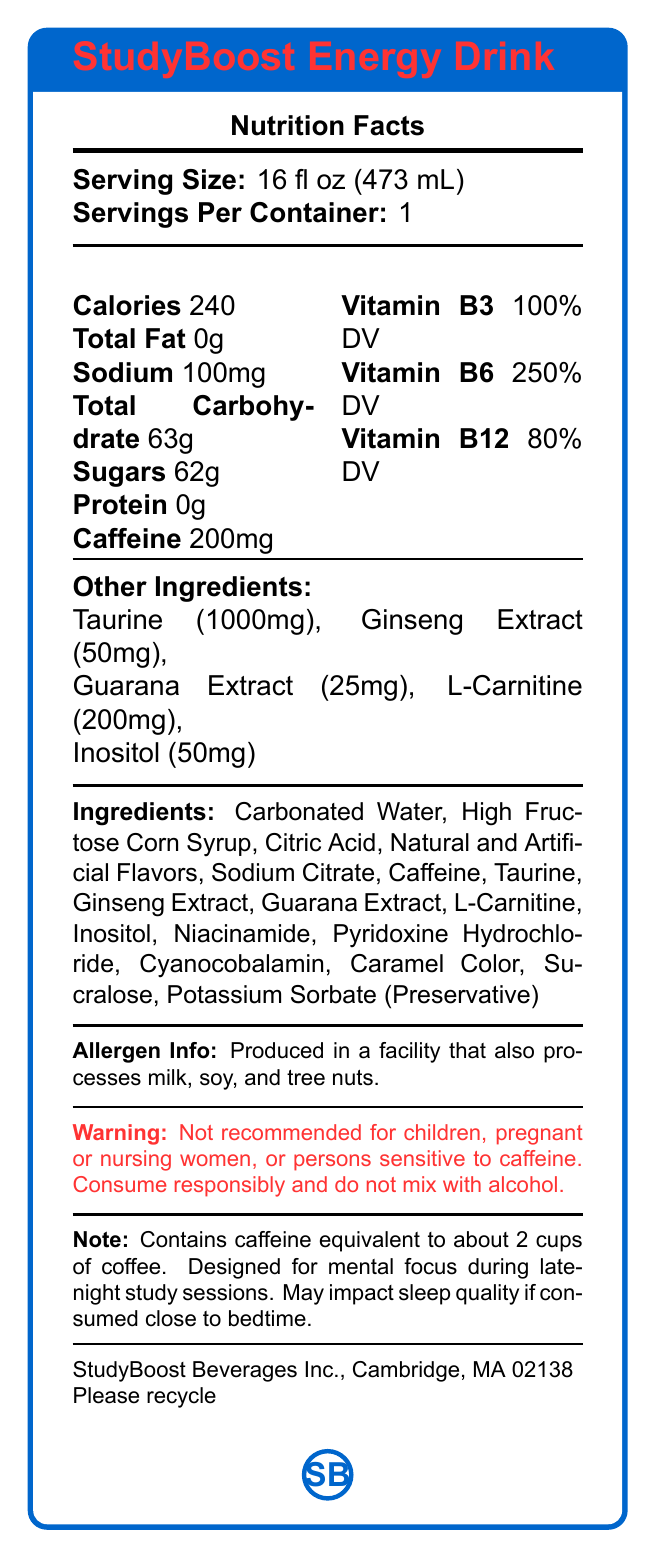what is the serving size? The serving size is explicitly mentioned at the top of the Nutrition Facts section.
Answer: 16 fl oz (473 mL) how many calories are in one serving? The calorie count is listed directly under "Calories" in the Nutrition Facts.
Answer: 240 what is the amount of caffeine in the drink? The caffeine content is listed along with other nutritional information.
Answer: 200mg how much sugar is in one serving of the energy drink? The sugar content is listed under "Sugars" in the Nutrition Facts section.
Answer: 62g which vitamins are included in this drink, and what are their daily values? The vitamins and their daily values are listed in the Nutrition Facts section.
Answer: Vitamin B3 (100% DV), Vitamin B6 (250% DV), Vitamin B12 (80% DV) how much sodium does this energy drink contain? Sodium content can be found in the standard nutritional listing in the Nutrition Facts section.
Answer: 100mg which of the following is not an ingredient in StudyBoost Energy Drink? A. Ginseng Extract B. L-Carnitine C. Vitamin D D. Citric Acid Vitamin D is not listed in the ingredients section.
Answer: C what is the purpose of this energy drink as mentioned in the document? A. Weight loss B. Mental focus and energy C. Muscle building D. Hydration The note at the bottom of the document states that the drink is designed for mental focus and energy for late-night study sessions.
Answer: B is the StudyBoost Energy Drink recommended for children or pregnant women? The consumer warning explicitly states that it is not recommended for children or pregnant or nursing women.
Answer: No summarize the main idea of this Nutrition Facts Label. The document provides detailed nutritional information, ingredient listing, and consumer warnings for the StudyBoost Energy Drink, emphasizing its components, servings, and usage warnings.
Answer: The StudyBoost Energy Drink provides information on its nutritional content, ingredients, and warnings. Each 16 fl oz serving contains 240 calories, 200mg of caffeine, high amounts of vitamins B3, B6, and B12, and significant sugars. The drink contains additional ingredients such as taurine, ginseng extract, and guarana extract and should be consumed responsibly, particularly due to its high caffeine content. how much taurine is present in the drink? The content of taurine is listed under "Other Ingredients".
Answer: 1000mg what are the possible allergens in this drink? The allergen information states that the product is produced in a facility that processes milk, soy, and tree nuts.
Answer: Milk, soy, and tree nuts is the energy drink suitable for mixing with alcohol? The consumer warning advises not to mix the energy drink with alcohol.
Answer: No what is the percentage Daily Value (% DV) of Vitamin B6 in this energy drink? The % DV for Vitamin B6 is listed in the Nutrition Facts section.
Answer: 250% DV can you determine the cost of the energy drink from this document? The document does not provide any pricing information for the energy drink.
Answer: Cannot be determined 